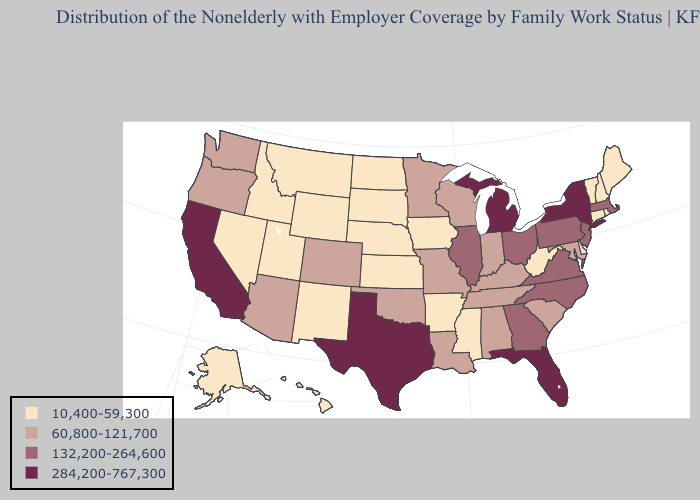Among the states that border New Hampshire , does Massachusetts have the highest value?
Quick response, please. Yes. Among the states that border Illinois , which have the lowest value?
Answer briefly. Iowa. Does the first symbol in the legend represent the smallest category?
Give a very brief answer. Yes. Name the states that have a value in the range 284,200-767,300?
Concise answer only. California, Florida, Michigan, New York, Texas. Does the map have missing data?
Keep it brief. No. What is the lowest value in the MidWest?
Be succinct. 10,400-59,300. What is the highest value in the South ?
Quick response, please. 284,200-767,300. Among the states that border South Dakota , which have the highest value?
Be succinct. Minnesota. What is the lowest value in states that border Kansas?
Answer briefly. 10,400-59,300. What is the value of Montana?
Give a very brief answer. 10,400-59,300. What is the value of Illinois?
Concise answer only. 132,200-264,600. Name the states that have a value in the range 284,200-767,300?
Give a very brief answer. California, Florida, Michigan, New York, Texas. Among the states that border Washington , does Idaho have the highest value?
Concise answer only. No. Name the states that have a value in the range 60,800-121,700?
Answer briefly. Alabama, Arizona, Colorado, Indiana, Kentucky, Louisiana, Maryland, Minnesota, Missouri, Oklahoma, Oregon, South Carolina, Tennessee, Washington, Wisconsin. Name the states that have a value in the range 132,200-264,600?
Keep it brief. Georgia, Illinois, Massachusetts, New Jersey, North Carolina, Ohio, Pennsylvania, Virginia. 